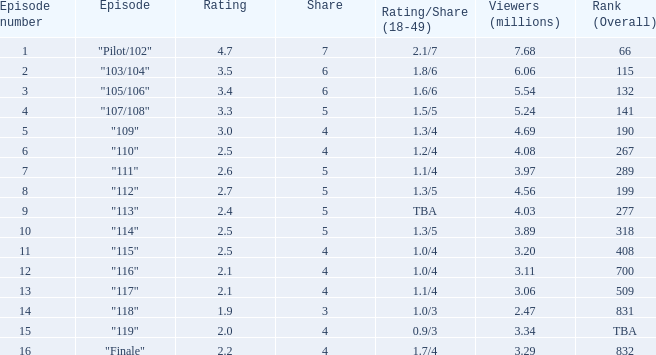47 million spectators? 0.0. 